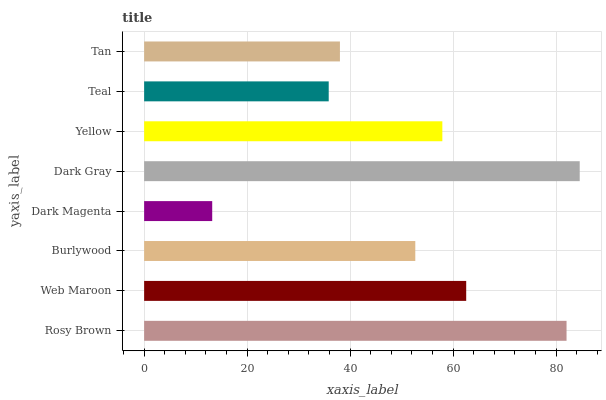Is Dark Magenta the minimum?
Answer yes or no. Yes. Is Dark Gray the maximum?
Answer yes or no. Yes. Is Web Maroon the minimum?
Answer yes or no. No. Is Web Maroon the maximum?
Answer yes or no. No. Is Rosy Brown greater than Web Maroon?
Answer yes or no. Yes. Is Web Maroon less than Rosy Brown?
Answer yes or no. Yes. Is Web Maroon greater than Rosy Brown?
Answer yes or no. No. Is Rosy Brown less than Web Maroon?
Answer yes or no. No. Is Yellow the high median?
Answer yes or no. Yes. Is Burlywood the low median?
Answer yes or no. Yes. Is Tan the high median?
Answer yes or no. No. Is Rosy Brown the low median?
Answer yes or no. No. 